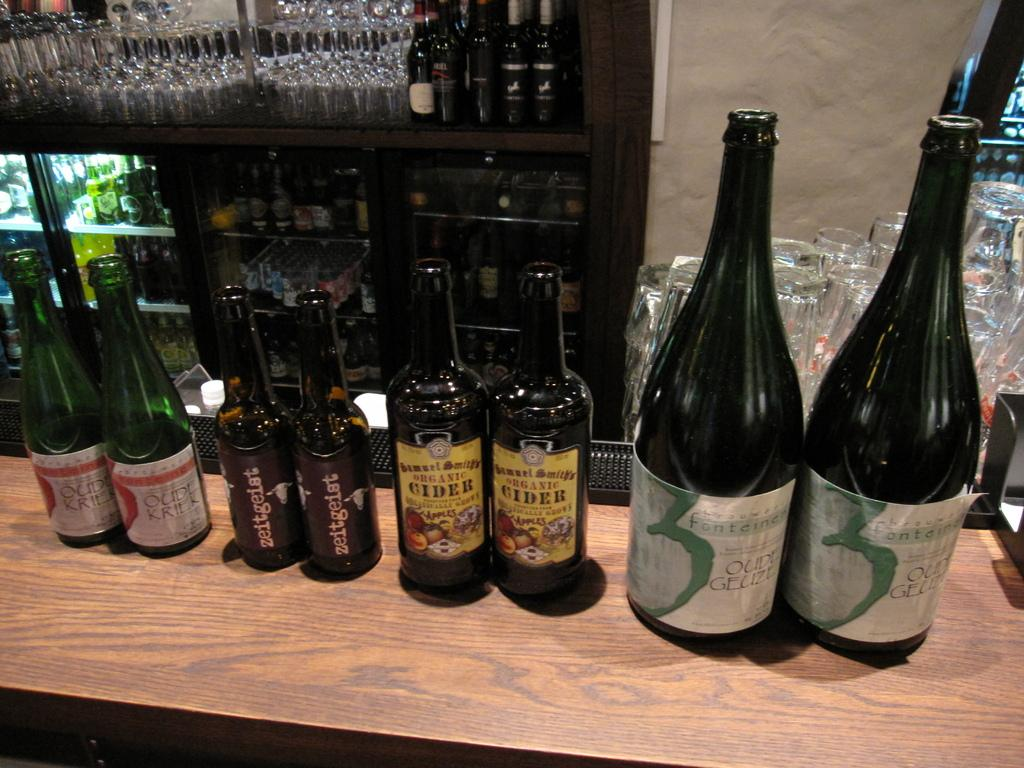<image>
Describe the image concisely. the word cider is on the front of a bottle 